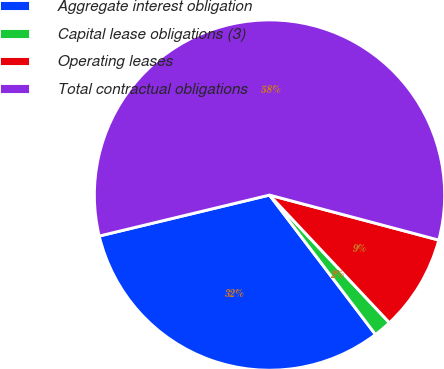<chart> <loc_0><loc_0><loc_500><loc_500><pie_chart><fcel>Aggregate interest obligation<fcel>Capital lease obligations (3)<fcel>Operating leases<fcel>Total contractual obligations<nl><fcel>31.58%<fcel>1.66%<fcel>8.86%<fcel>57.89%<nl></chart> 